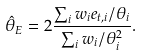Convert formula to latex. <formula><loc_0><loc_0><loc_500><loc_500>\hat { \theta } _ { E } = 2 \frac { \sum _ { i } w _ { i } e _ { t , i } / \theta _ { i } } { \sum _ { i } w _ { i } / \theta _ { i } ^ { 2 } } .</formula> 